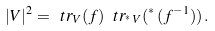<formula> <loc_0><loc_0><loc_500><loc_500>| V | ^ { 2 } = \ t r _ { V } ( f ) \, \ t r _ { ^ { * } \, V } ( { ^ { * } \, ( f ^ { - 1 } ) } ) \, .</formula> 